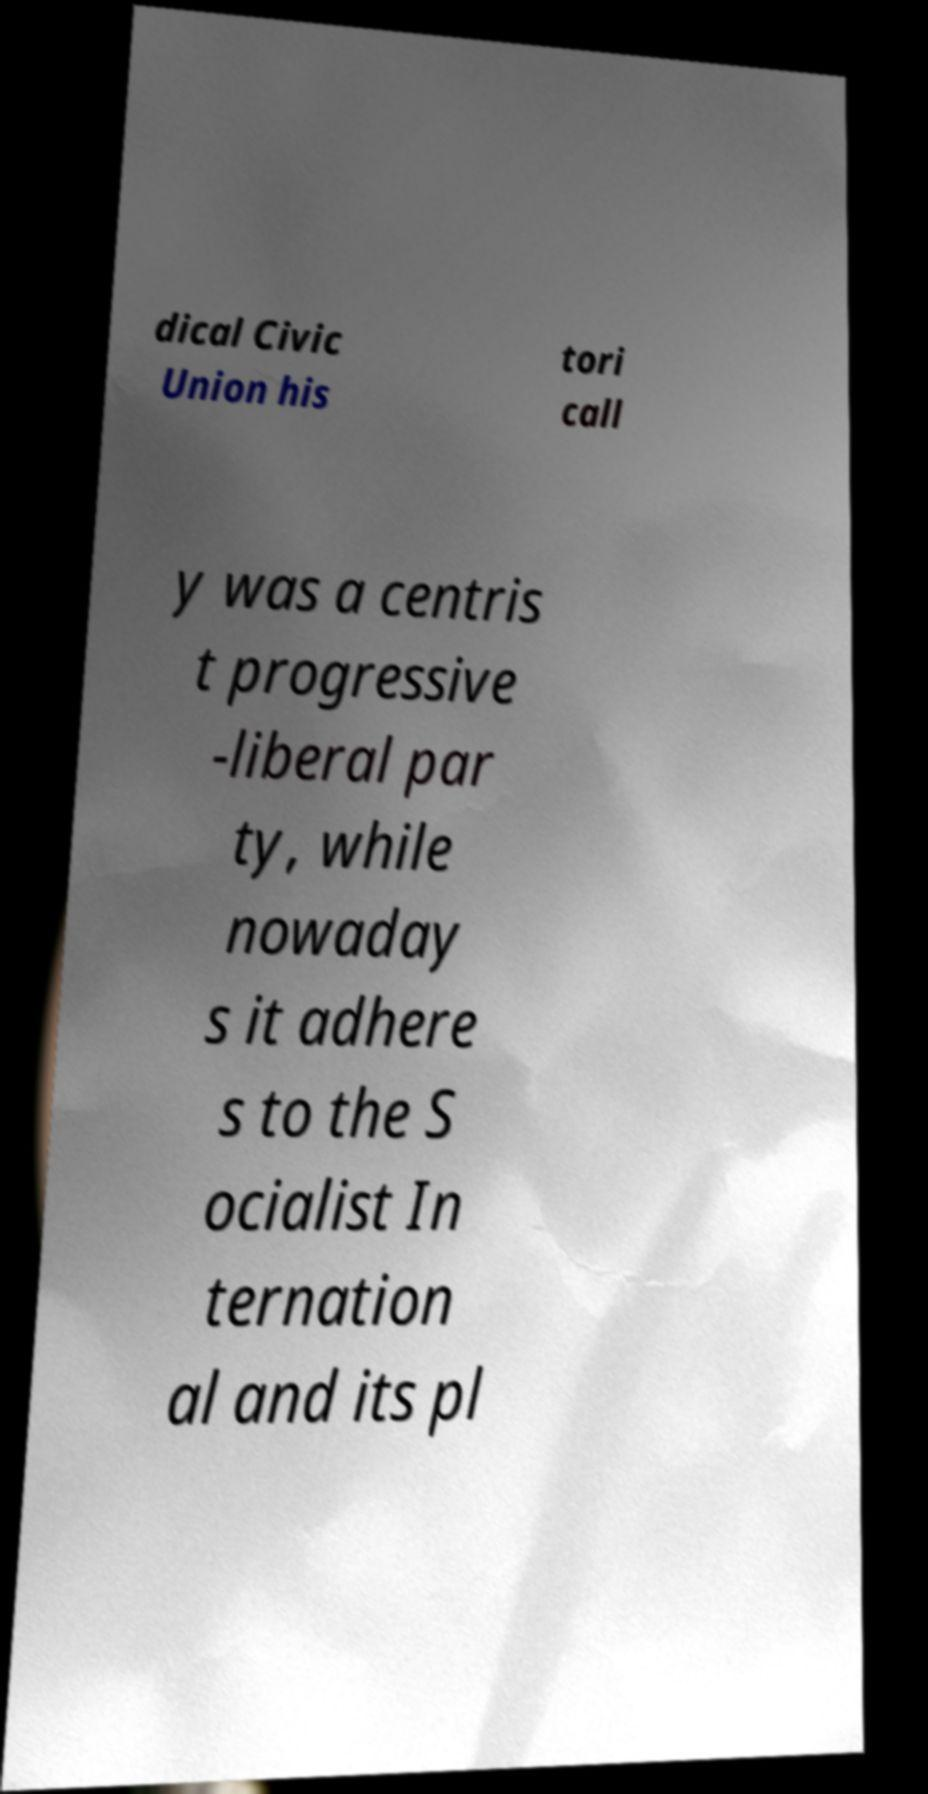There's text embedded in this image that I need extracted. Can you transcribe it verbatim? dical Civic Union his tori call y was a centris t progressive -liberal par ty, while nowaday s it adhere s to the S ocialist In ternation al and its pl 